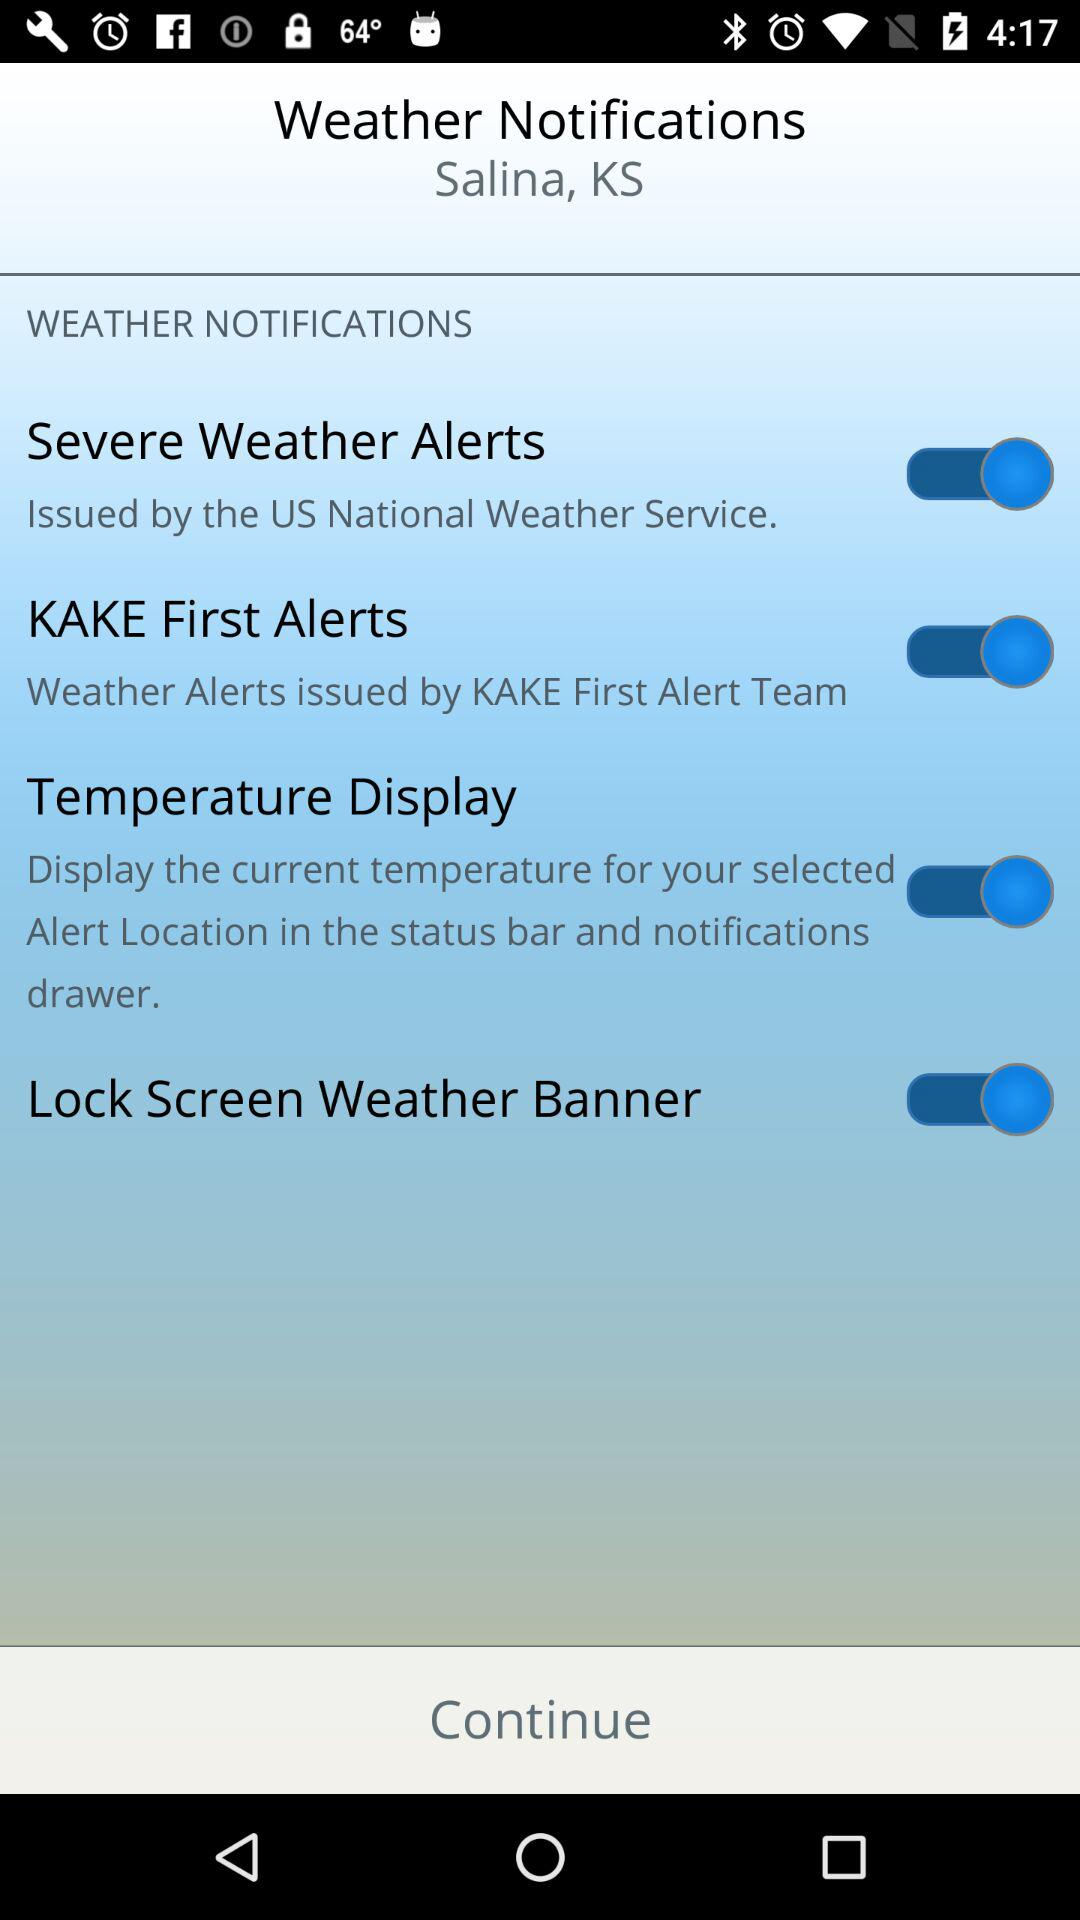What is the status of "KAKE First Alerts"? The status is "on". 